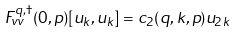Convert formula to latex. <formula><loc_0><loc_0><loc_500><loc_500>F ^ { q , \dagger } _ { v v } ( 0 , p ) [ u _ { k } , u _ { k } ] & = c _ { 2 } ( q , k , p ) u _ { 2 k }</formula> 